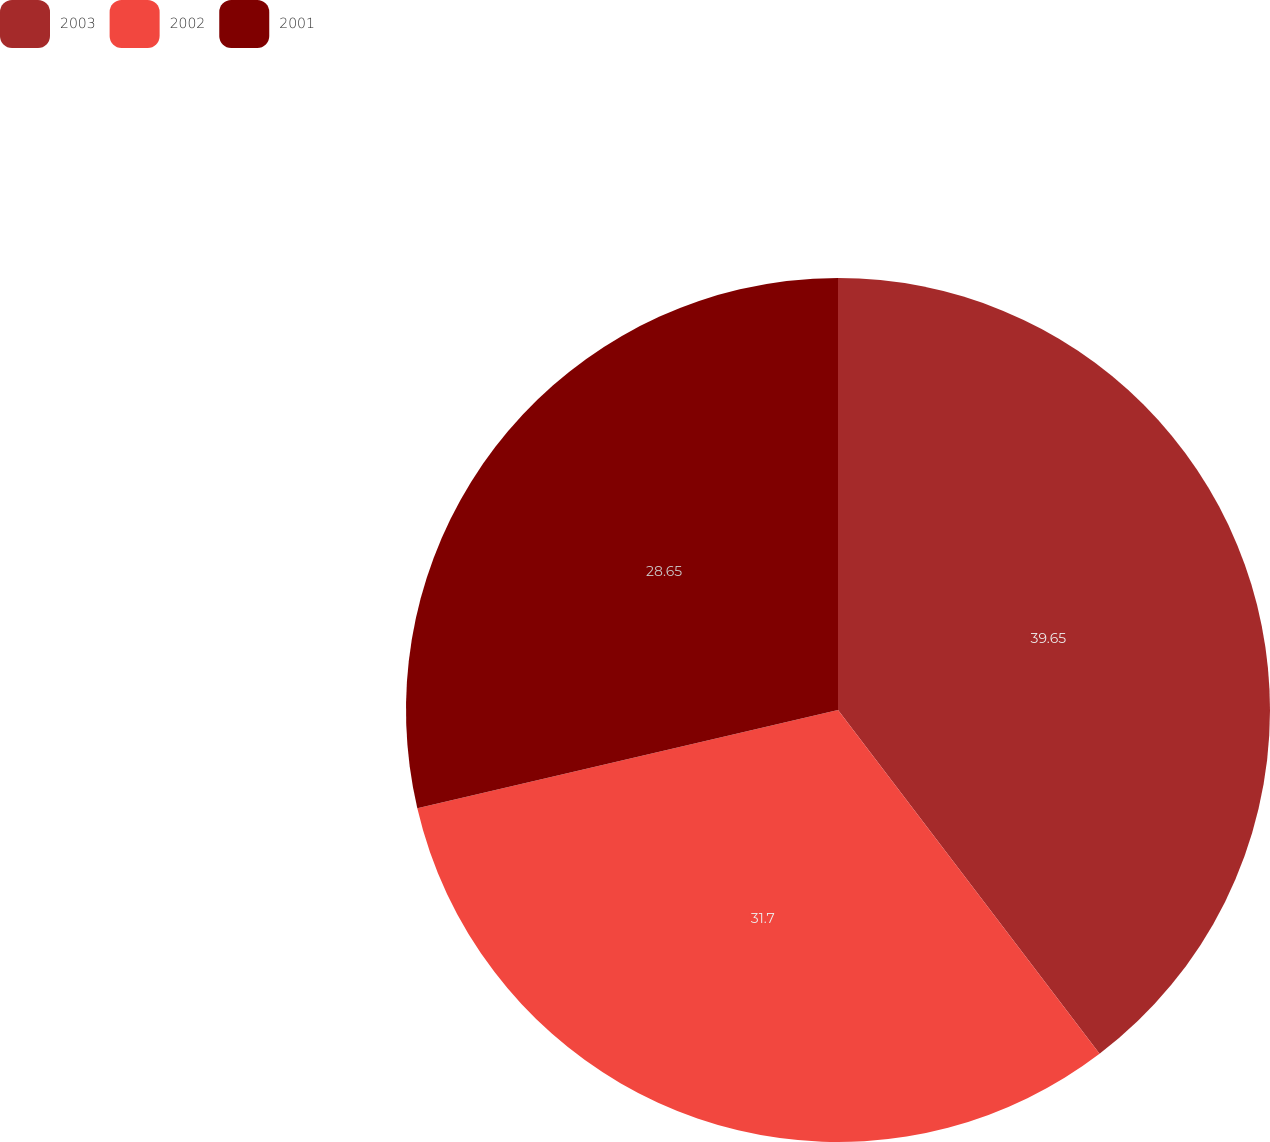Convert chart. <chart><loc_0><loc_0><loc_500><loc_500><pie_chart><fcel>2003<fcel>2002<fcel>2001<nl><fcel>39.65%<fcel>31.7%<fcel>28.65%<nl></chart> 